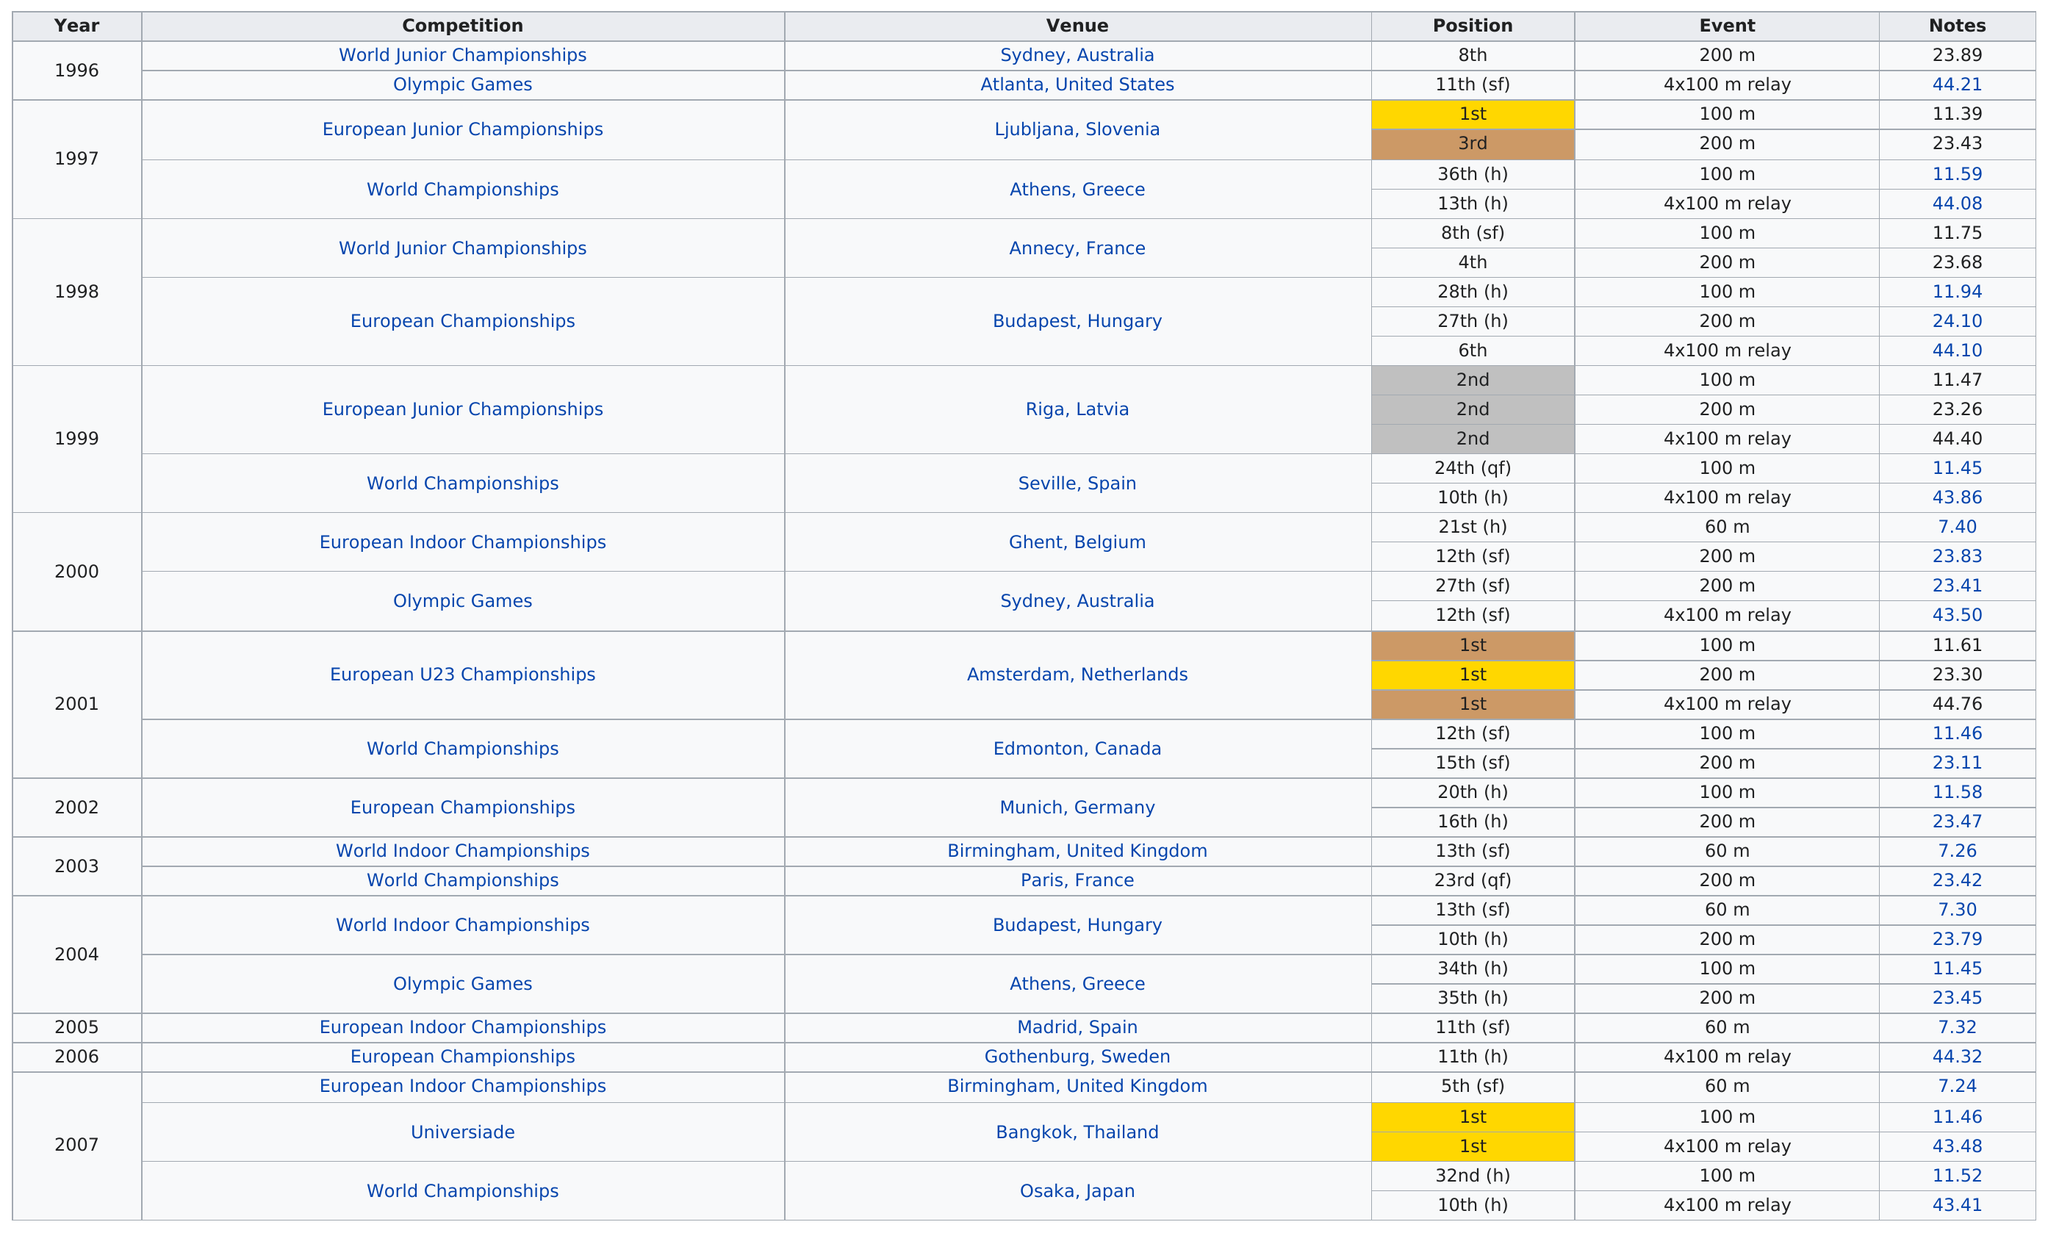Highlight a few significant elements in this photo. The runner had a total of six first place victories. The number of events that took place was 22. In 1999, the individual placed at least second in two competitions. She took part in a total of 22 events. Before the 2000 Olympic Games, Johanna's fastest 200m time was 23.26 seconds. 